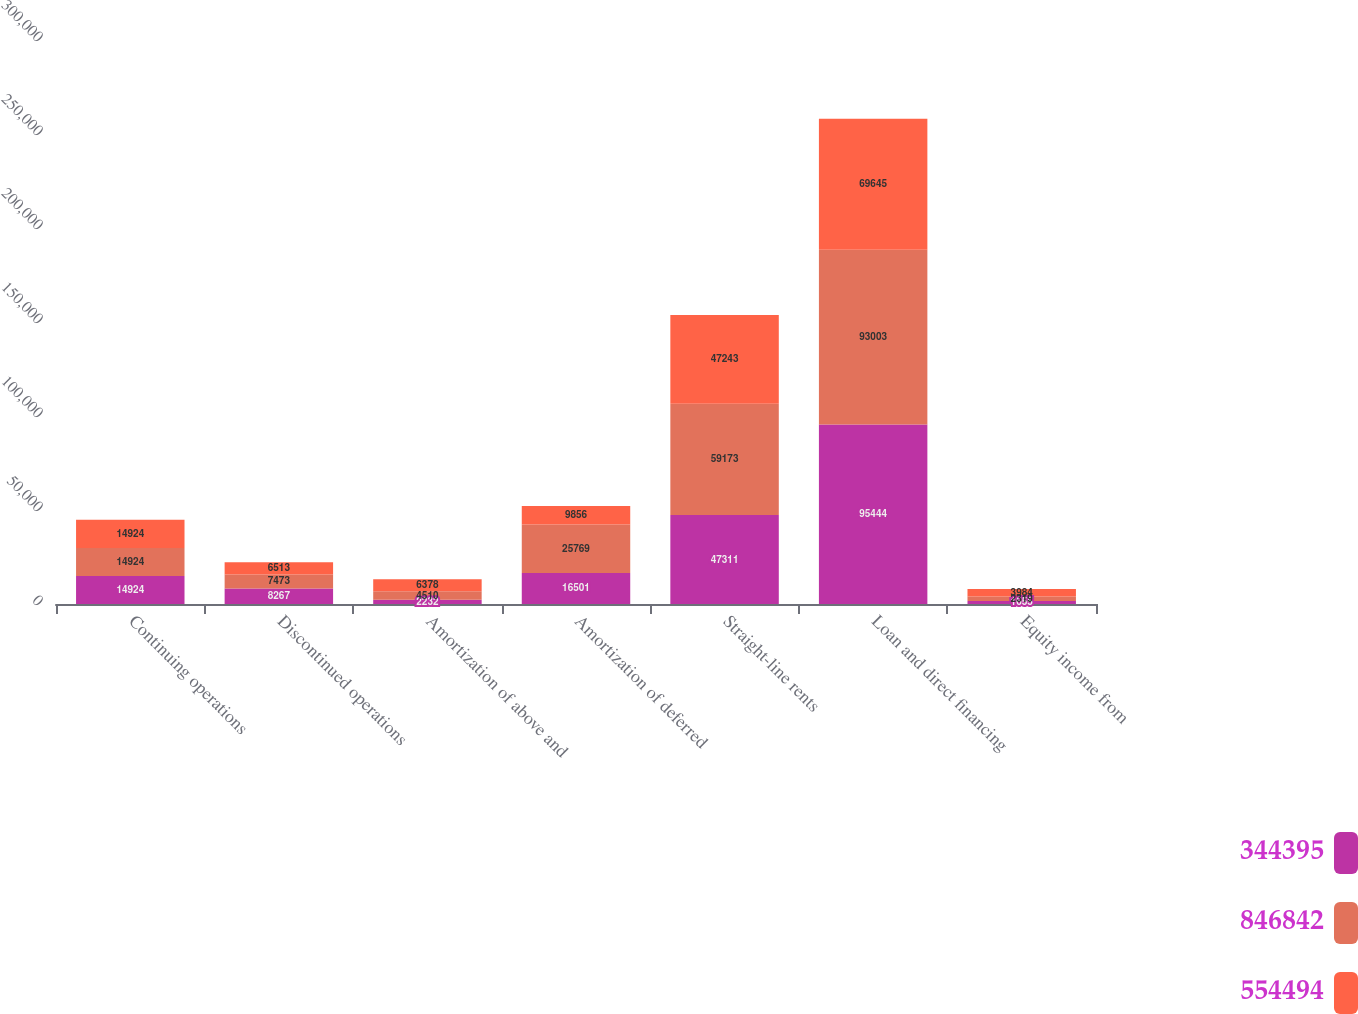<chart> <loc_0><loc_0><loc_500><loc_500><stacked_bar_chart><ecel><fcel>Continuing operations<fcel>Discontinued operations<fcel>Amortization of above and<fcel>Amortization of deferred<fcel>Straight-line rents<fcel>Loan and direct financing<fcel>Equity income from<nl><fcel>344395<fcel>14924<fcel>8267<fcel>2232<fcel>16501<fcel>47311<fcel>95444<fcel>1655<nl><fcel>846842<fcel>14924<fcel>7473<fcel>4510<fcel>25769<fcel>59173<fcel>93003<fcel>2319<nl><fcel>554494<fcel>14924<fcel>6513<fcel>6378<fcel>9856<fcel>47243<fcel>69645<fcel>3984<nl></chart> 